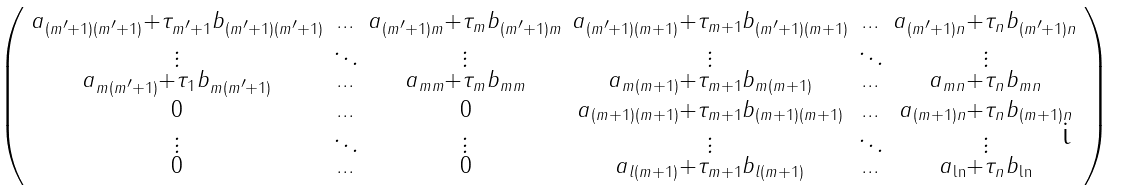Convert formula to latex. <formula><loc_0><loc_0><loc_500><loc_500>\begin{psmallmatrix} a _ { ( m ^ { \prime } + 1 ) ( m ^ { \prime } + 1 ) } + \tau _ { m ^ { \prime } + 1 } b _ { ( m ^ { \prime } + 1 ) ( m ^ { \prime } + 1 ) } & \hdots & a _ { ( m ^ { \prime } + 1 ) m } + \tau _ { m } b _ { ( m ^ { \prime } + 1 ) m } & a _ { ( m ^ { \prime } + 1 ) ( m + 1 ) } + \tau _ { m + 1 } b _ { ( m ^ { \prime } + 1 ) ( m + 1 ) } & \hdots & a _ { ( m ^ { \prime } + 1 ) n } + \tau _ { n } b _ { ( m ^ { \prime } + 1 ) n } \\ \vdots & \ddots & \vdots & \vdots & \ddots & \vdots \\ a _ { m ( m ^ { \prime } + 1 ) } + \tau _ { 1 } b _ { m ( m ^ { \prime } + 1 ) } & \hdots & a _ { m m } + \tau _ { m } b _ { m m } & a _ { m ( m + 1 ) } + \tau _ { m + 1 } b _ { m ( m + 1 ) } & \hdots & a _ { m n } + \tau _ { n } b _ { m n } \\ 0 & \hdots & 0 & a _ { ( m + 1 ) ( m + 1 ) } + \tau _ { m + 1 } b _ { ( m + 1 ) ( m + 1 ) } & \hdots & a _ { ( m + 1 ) n } + \tau _ { n } b _ { ( m + 1 ) n } \\ \vdots & \ddots & \vdots & \vdots & \ddots & \vdots \\ 0 & \hdots & 0 & a _ { l ( m + 1 ) } + \tau _ { m + 1 } b _ { l ( m + 1 ) } & \hdots & a _ { \ln } + \tau _ { n } b _ { \ln } \end{psmallmatrix}</formula> 